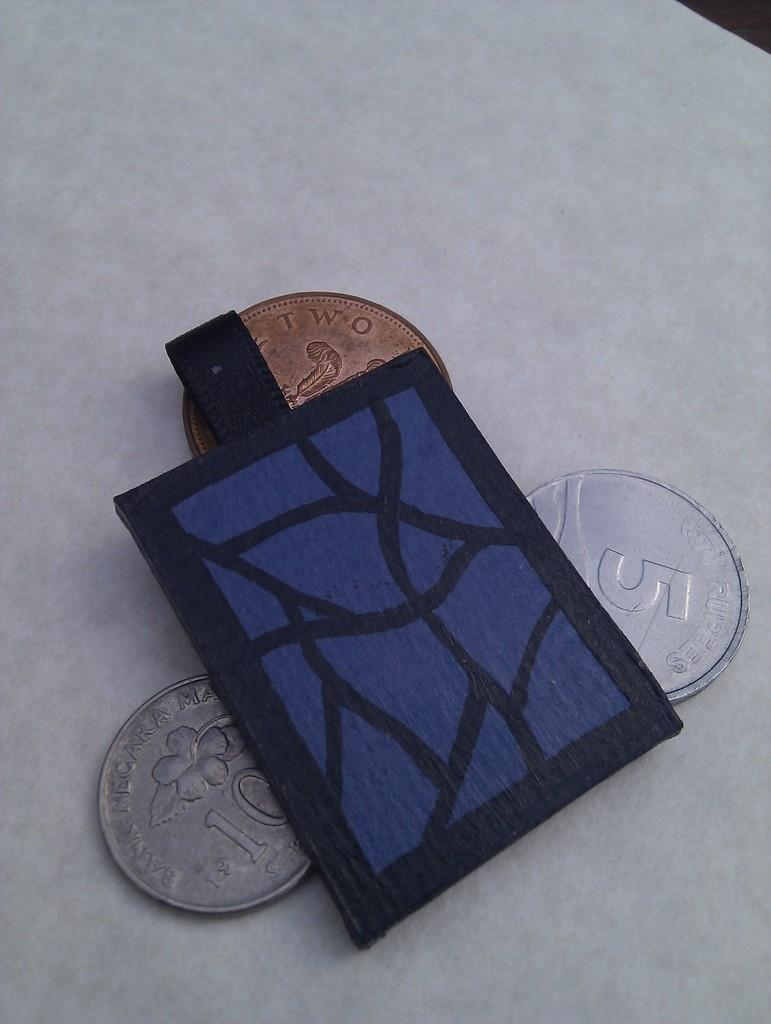What objects can be seen in the image? There are coins and a small bag in the image. Where are the coins and small bag located? The coins and small bag are placed on a table. How many giraffes can be seen on the island in the image? There are no giraffes or islands present in the image; it only features coins and a small bag on a table. 